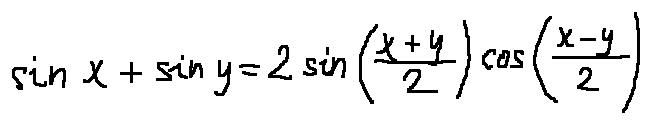Convert formula to latex. <formula><loc_0><loc_0><loc_500><loc_500>\sin x + \sin y = 2 \sin ( \frac { x + y } { 2 } ) \cos ( \frac { x - y } { 2 } )</formula> 